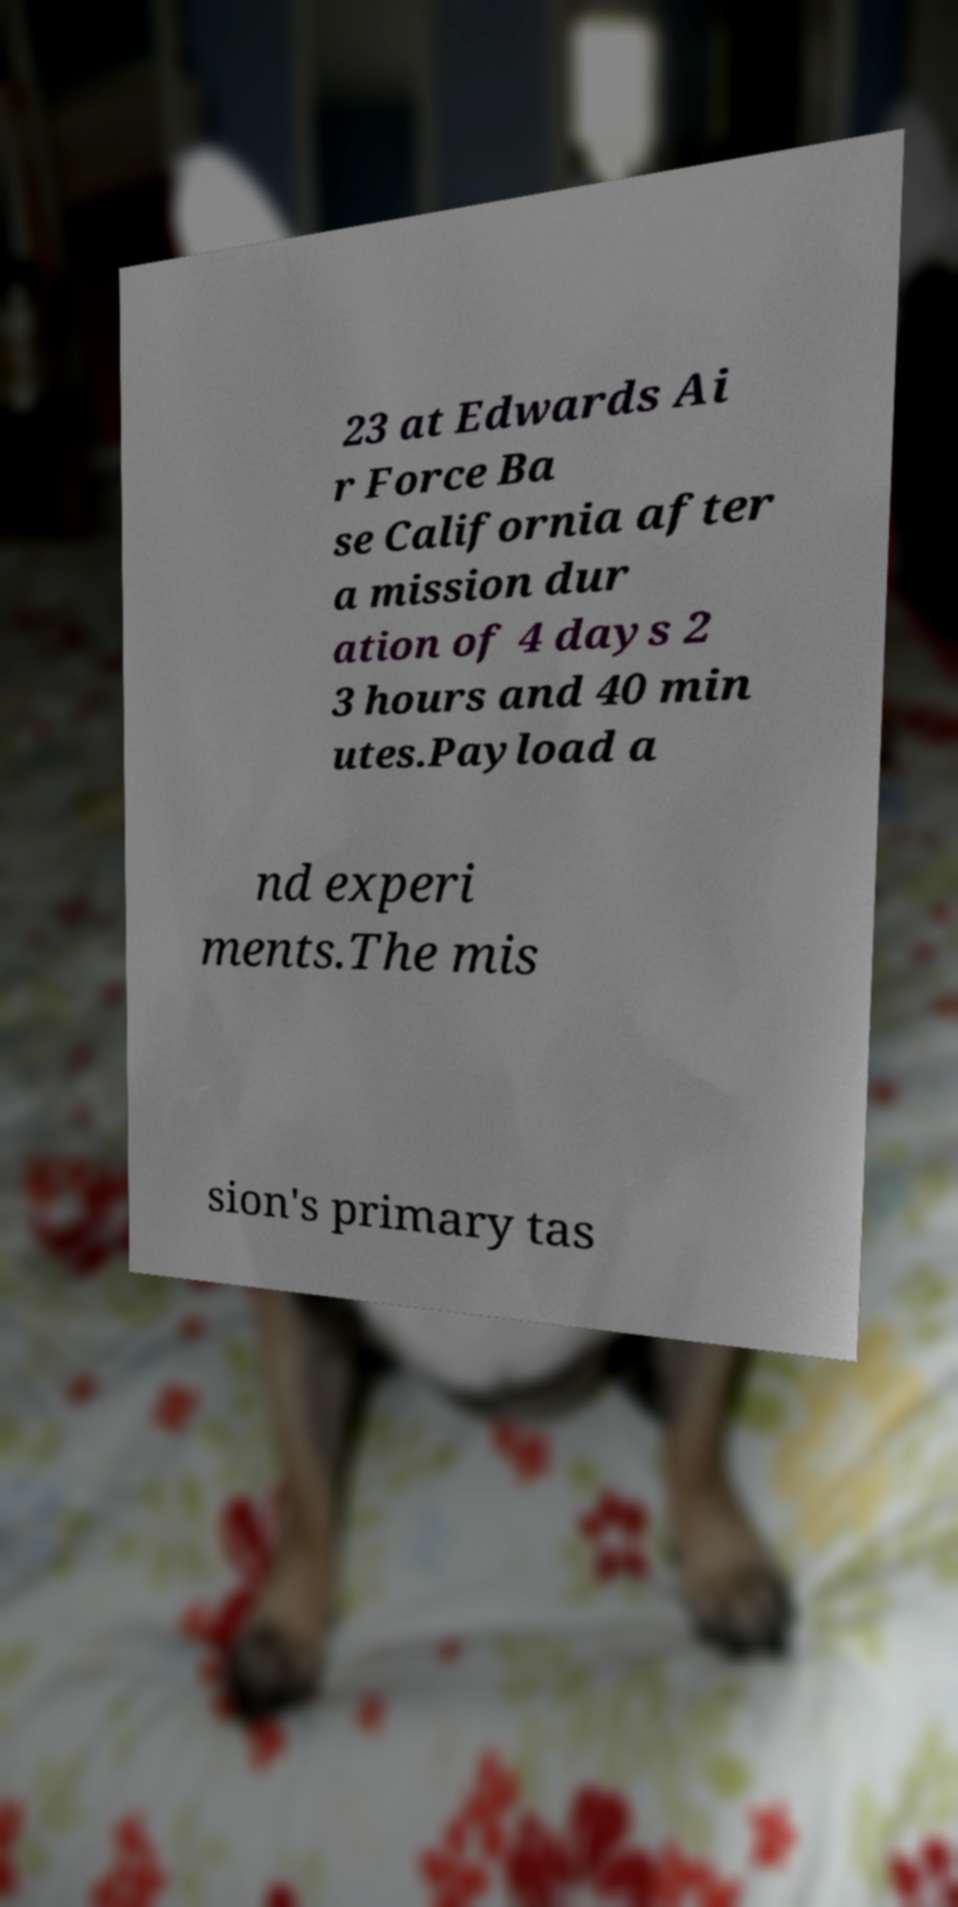Could you extract and type out the text from this image? 23 at Edwards Ai r Force Ba se California after a mission dur ation of 4 days 2 3 hours and 40 min utes.Payload a nd experi ments.The mis sion's primary tas 